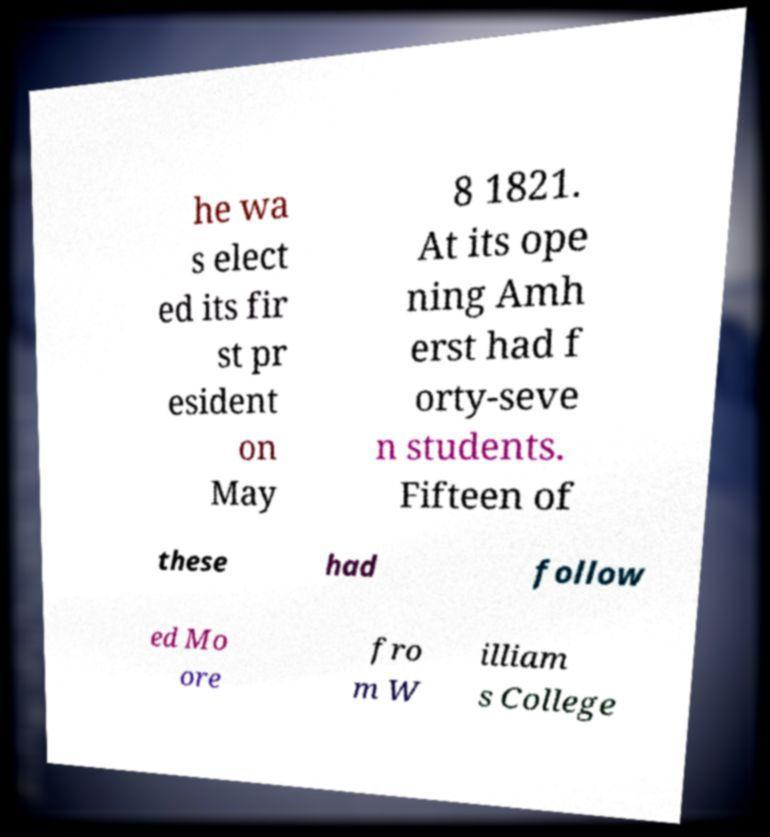I need the written content from this picture converted into text. Can you do that? he wa s elect ed its fir st pr esident on May 8 1821. At its ope ning Amh erst had f orty-seve n students. Fifteen of these had follow ed Mo ore fro m W illiam s College 